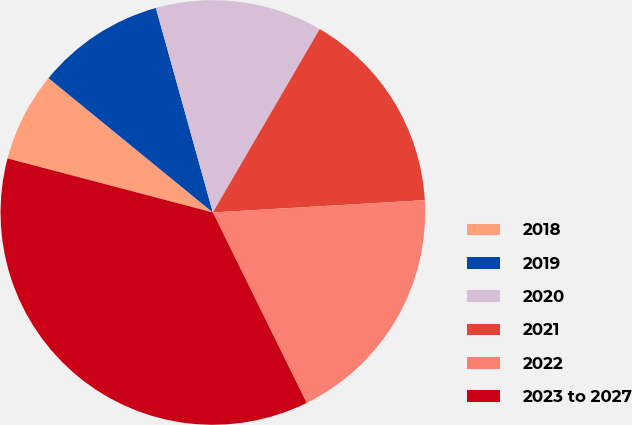Convert chart to OTSL. <chart><loc_0><loc_0><loc_500><loc_500><pie_chart><fcel>2018<fcel>2019<fcel>2020<fcel>2021<fcel>2022<fcel>2023 to 2027<nl><fcel>6.81%<fcel>9.77%<fcel>12.72%<fcel>15.68%<fcel>18.64%<fcel>36.38%<nl></chart> 